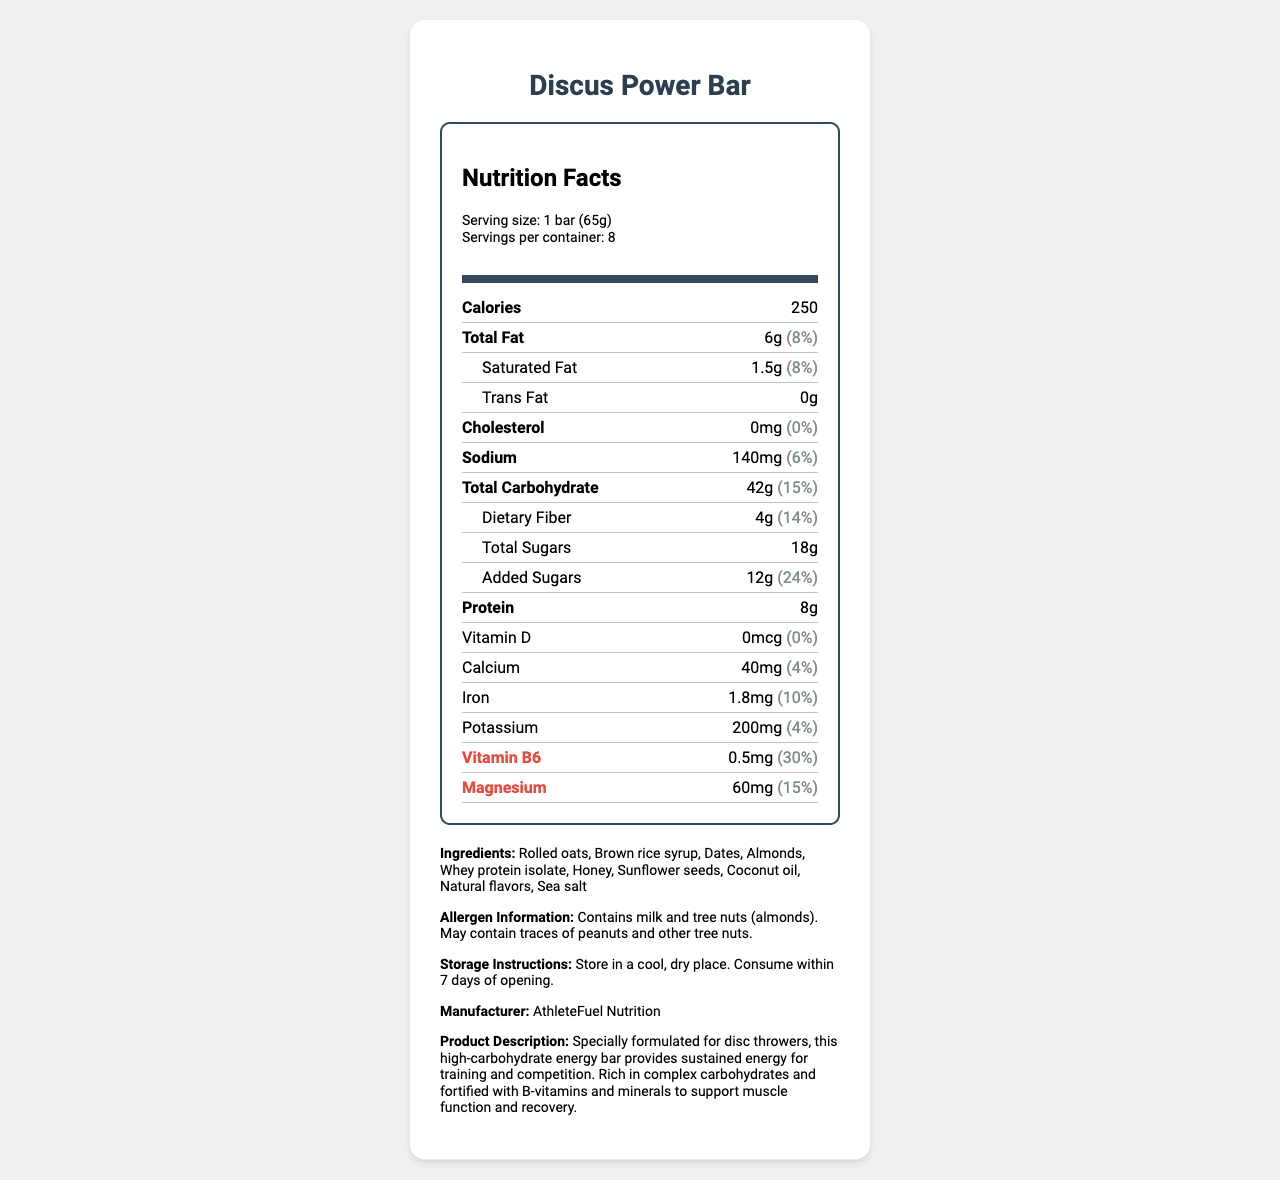What is the serving size of the Discus Power Bar? The serving size is mentioned at the beginning of the nutrition facts section.
Answer: 1 bar (65g) How many calories are in one serving of the Discus Power Bar? The calories per serving are listed directly under the "Calories" section.
Answer: 250 What percentage of the daily value of total fat does one serving of the Discus Power Bar provide? The daily value percentage for total fat is provided next to the amount of fat.
Answer: 8% How much dietary fiber is contained in one serving of the Discus Power Bar? The dietary fiber content is listed under the total carbohydrates section.
Answer: 4g How much protein is in one serving of the Discus Power Bar? The protein content is specified near the bottom of the list of nutrients.
Answer: 8g What is the daily value percentage of Vitamin B6 in one serving? A. 10% B. 30% C. 50% D. 60% The daily value percentage for Vitamin B6 is listed as 30%.
Answer: B. 30% Which of the following is an ingredient in the Discus Power Bar? 1. Rolled oats 2. Corn syrup 3. Soy protein isolate 4. Peanut butter Rolled oats is included in the ingredient list, while the other options are not.
Answer: 1. Rolled oats Does the Discus Power Bar contain added sugars? The label lists added sugars as 12g.
Answer: Yes Is this product suitable for someone with a peanut allergy? The allergen information indicates that it may contain traces of peanuts.
Answer: No Summarize the main idea of this document. The document includes detailed nutrition information, ingredient list, allergen warnings, and the product's specific benefits for disc throwers, emphasizing its role in providing energy and supporting muscle function and recovery.
Answer: This document provides the nutrition facts, ingredients, allergen information, and other details for the Discus Power Bar, which is a high-carbohydrate energy bar formulated specifically for disc throwers, designed to support sustained energy during training and competitions. Which minerals are listed in the nutrition facts? The minerals listed in the label are calcium (40mg), iron (1.8mg), magnesium (60mg), and potassium (200mg).
Answer: Calcium, Iron, Magnesium, Potassium What is the total amount of sugars in one serving, including added sugars? The label lists total sugars as 18g, which includes the 12g of added sugars.
Answer: 18g What is the primary purpose of the Discus Power Bar as described in the document? The product description states its formulation for providing sustained energy specifically for disc throwers.
Answer: To provide sustained energy for training and competition for disc throwers When should the Discus Power Bar be consumed after opening? The storage instructions specify consuming the bar within 7 days of opening.
Answer: Within 7 days How much calcium does one serving of the Discus Power Bar provide? A. 10mg B. 20mg C. 30mg D. 40mg The calcium content per serving is listed as 40mg.
Answer: D. 40mg What is the amount of trans fats in one serving of the Discus Power Bar? The amount of trans fats is listed as 0g on the label.
Answer: 0g Is the energy provided by this bar primarily from fats? The bar provides energy primarily from carbohydrates, as it contains 42g of total carbohydrates compared to 6g of total fat.
Answer: No How many servings are there in one container? The label states that there are 8 servings per container.
Answer: 8 What are the storage instructions for the Discus Power Bar? The storage instructions are provided towards the bottom of the document.
Answer: Store in a cool, dry place. Consume within 7 days of opening. Who is the manufacturer of the Discus Power Bar? The manufacturer is listed at the end of the document.
Answer: AthleteFuel Nutrition What is the cholesterol content in one serving of the Discus Power Bar? The cholesterol content is mentioned as 0mg in the nutrition facts.
Answer: 0mg 